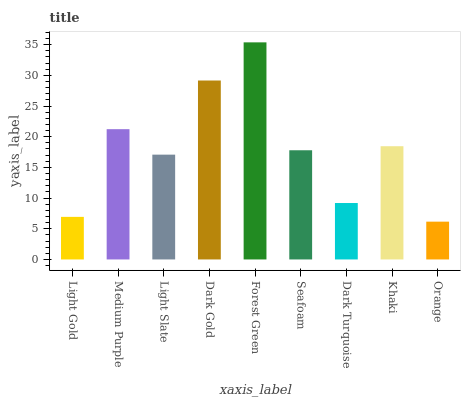Is Orange the minimum?
Answer yes or no. Yes. Is Forest Green the maximum?
Answer yes or no. Yes. Is Medium Purple the minimum?
Answer yes or no. No. Is Medium Purple the maximum?
Answer yes or no. No. Is Medium Purple greater than Light Gold?
Answer yes or no. Yes. Is Light Gold less than Medium Purple?
Answer yes or no. Yes. Is Light Gold greater than Medium Purple?
Answer yes or no. No. Is Medium Purple less than Light Gold?
Answer yes or no. No. Is Seafoam the high median?
Answer yes or no. Yes. Is Seafoam the low median?
Answer yes or no. Yes. Is Khaki the high median?
Answer yes or no. No. Is Dark Turquoise the low median?
Answer yes or no. No. 